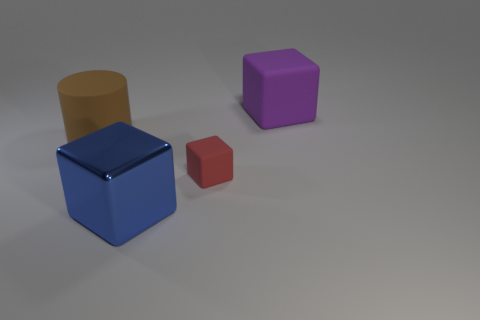Subtract all rubber cubes. How many cubes are left? 1 Subtract all red blocks. How many blocks are left? 2 Subtract 1 blocks. How many blocks are left? 2 Subtract all cubes. How many objects are left? 1 Add 1 small green rubber cylinders. How many objects exist? 5 Subtract all purple cylinders. How many purple blocks are left? 1 Subtract all metallic cylinders. Subtract all big shiny things. How many objects are left? 3 Add 2 rubber objects. How many rubber objects are left? 5 Add 3 tiny cyan blocks. How many tiny cyan blocks exist? 3 Subtract 0 yellow cylinders. How many objects are left? 4 